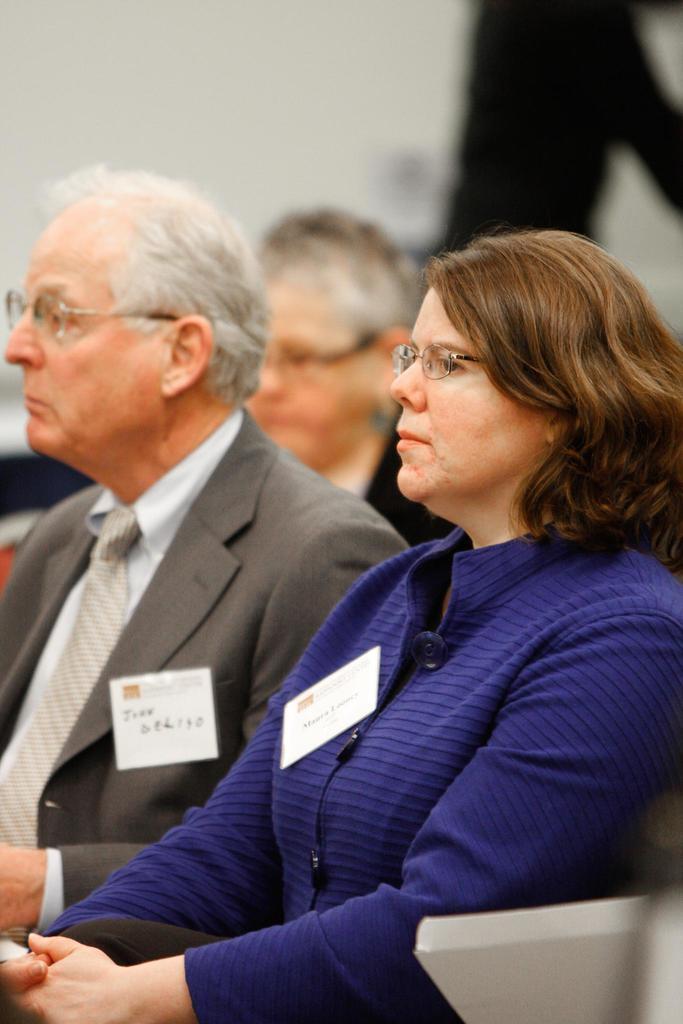Could you give a brief overview of what you see in this image? In the center of the image we can see three persons are sitting. At the top of the image wall is there. 